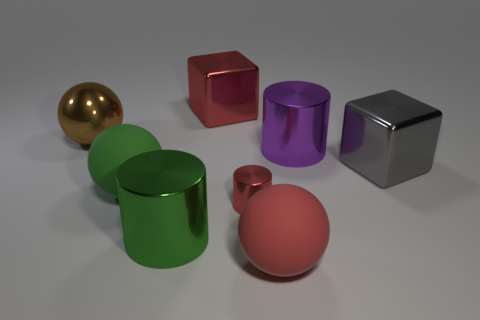Does the big block on the right side of the red rubber sphere have the same material as the small red thing?
Offer a terse response. Yes. Are there any other things that are the same size as the red shiny cylinder?
Keep it short and to the point. No. Are there any red blocks in front of the big purple metal cylinder?
Your answer should be compact. No. What is the color of the ball behind the big metallic block right of the red thing behind the large gray shiny cube?
Offer a terse response. Brown. There is a gray metallic object that is the same size as the purple cylinder; what shape is it?
Provide a succinct answer. Cube. Are there more big red things than cyan cylinders?
Provide a short and direct response. Yes. Is there a big red cube that is behind the large brown metal thing that is on the left side of the large green sphere?
Ensure brevity in your answer.  Yes. There is another big object that is the same shape as the purple object; what is its color?
Give a very brief answer. Green. Is there any other thing that has the same shape as the tiny shiny object?
Ensure brevity in your answer.  Yes. There is another tiny thing that is the same material as the brown thing; what is its color?
Keep it short and to the point. Red. 